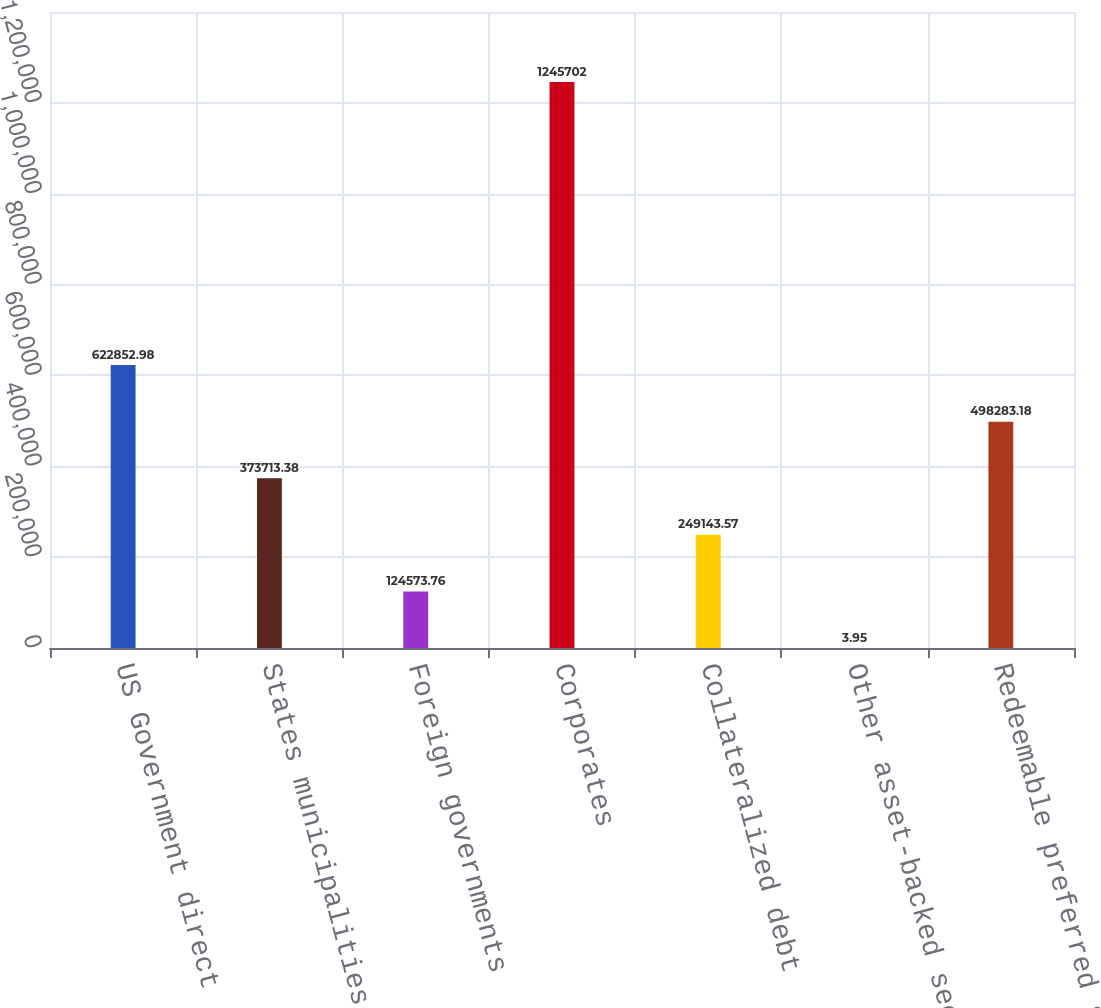Convert chart to OTSL. <chart><loc_0><loc_0><loc_500><loc_500><bar_chart><fcel>US Government direct<fcel>States municipalities and<fcel>Foreign governments<fcel>Corporates<fcel>Collateralized debt<fcel>Other asset-backed securities<fcel>Redeemable preferred stocks<nl><fcel>622853<fcel>373713<fcel>124574<fcel>1.2457e+06<fcel>249144<fcel>3.95<fcel>498283<nl></chart> 